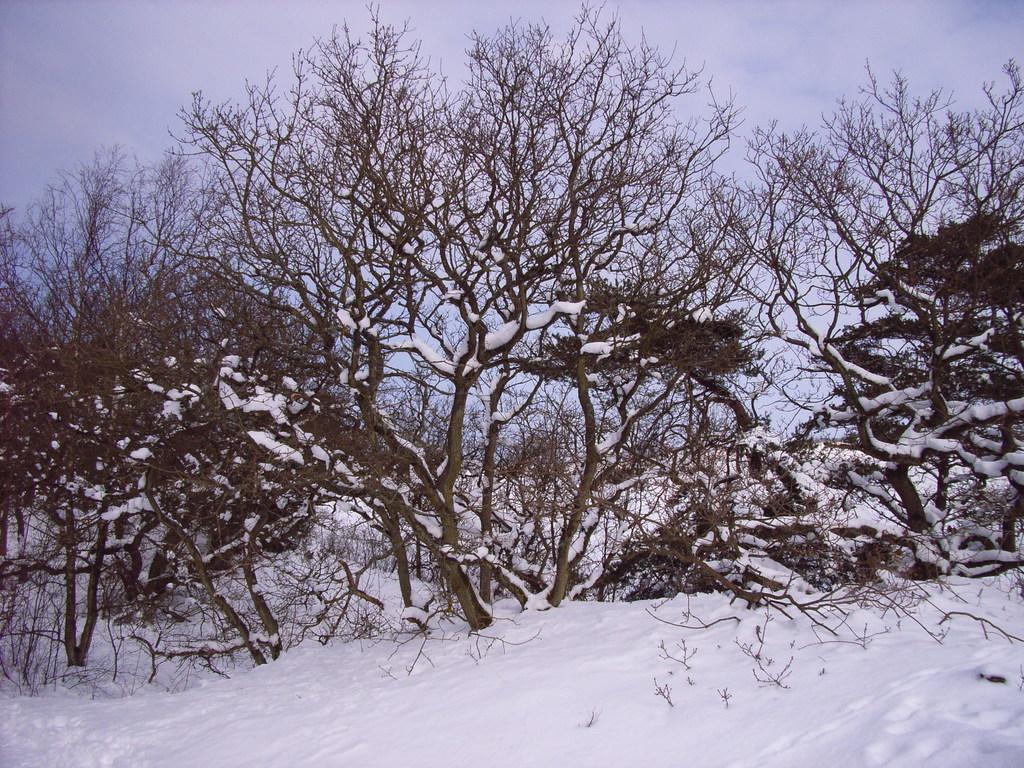What can be seen in the snow in the image? There are twigs in the snow in the image. What is visible in the background of the image? There are plants covered with snow in the background of the image. What is visible at the top of the image? The sky is visible at the top of the image. How many units of mice can be observed in the image? There are no mice present in the image, so it is not possible to determine the number of units. 